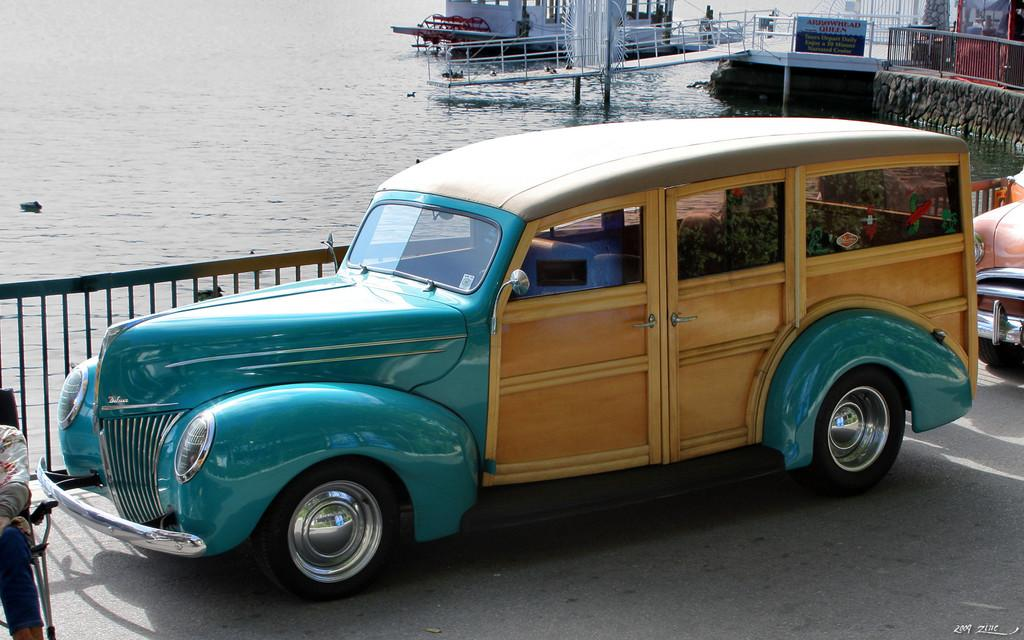What types of transportation can be seen on the road in the image? There are vehicles on the road in the image. What architectural feature is present in the image? There are iron grilles in the image. What body of water is visible in the image? There is a boat on the water in the image. What structure is associated with the boat in the image? There is a passenger boat ramp in the image. What object can be seen in the image that might be used for displaying information or advertising? There is a board in the image. What type of substance is being polished by the women in the image? There are no women or polishing activity present in the image. What type of polish is being used by the women in the image? There are no women or polishing activity present in the image. 